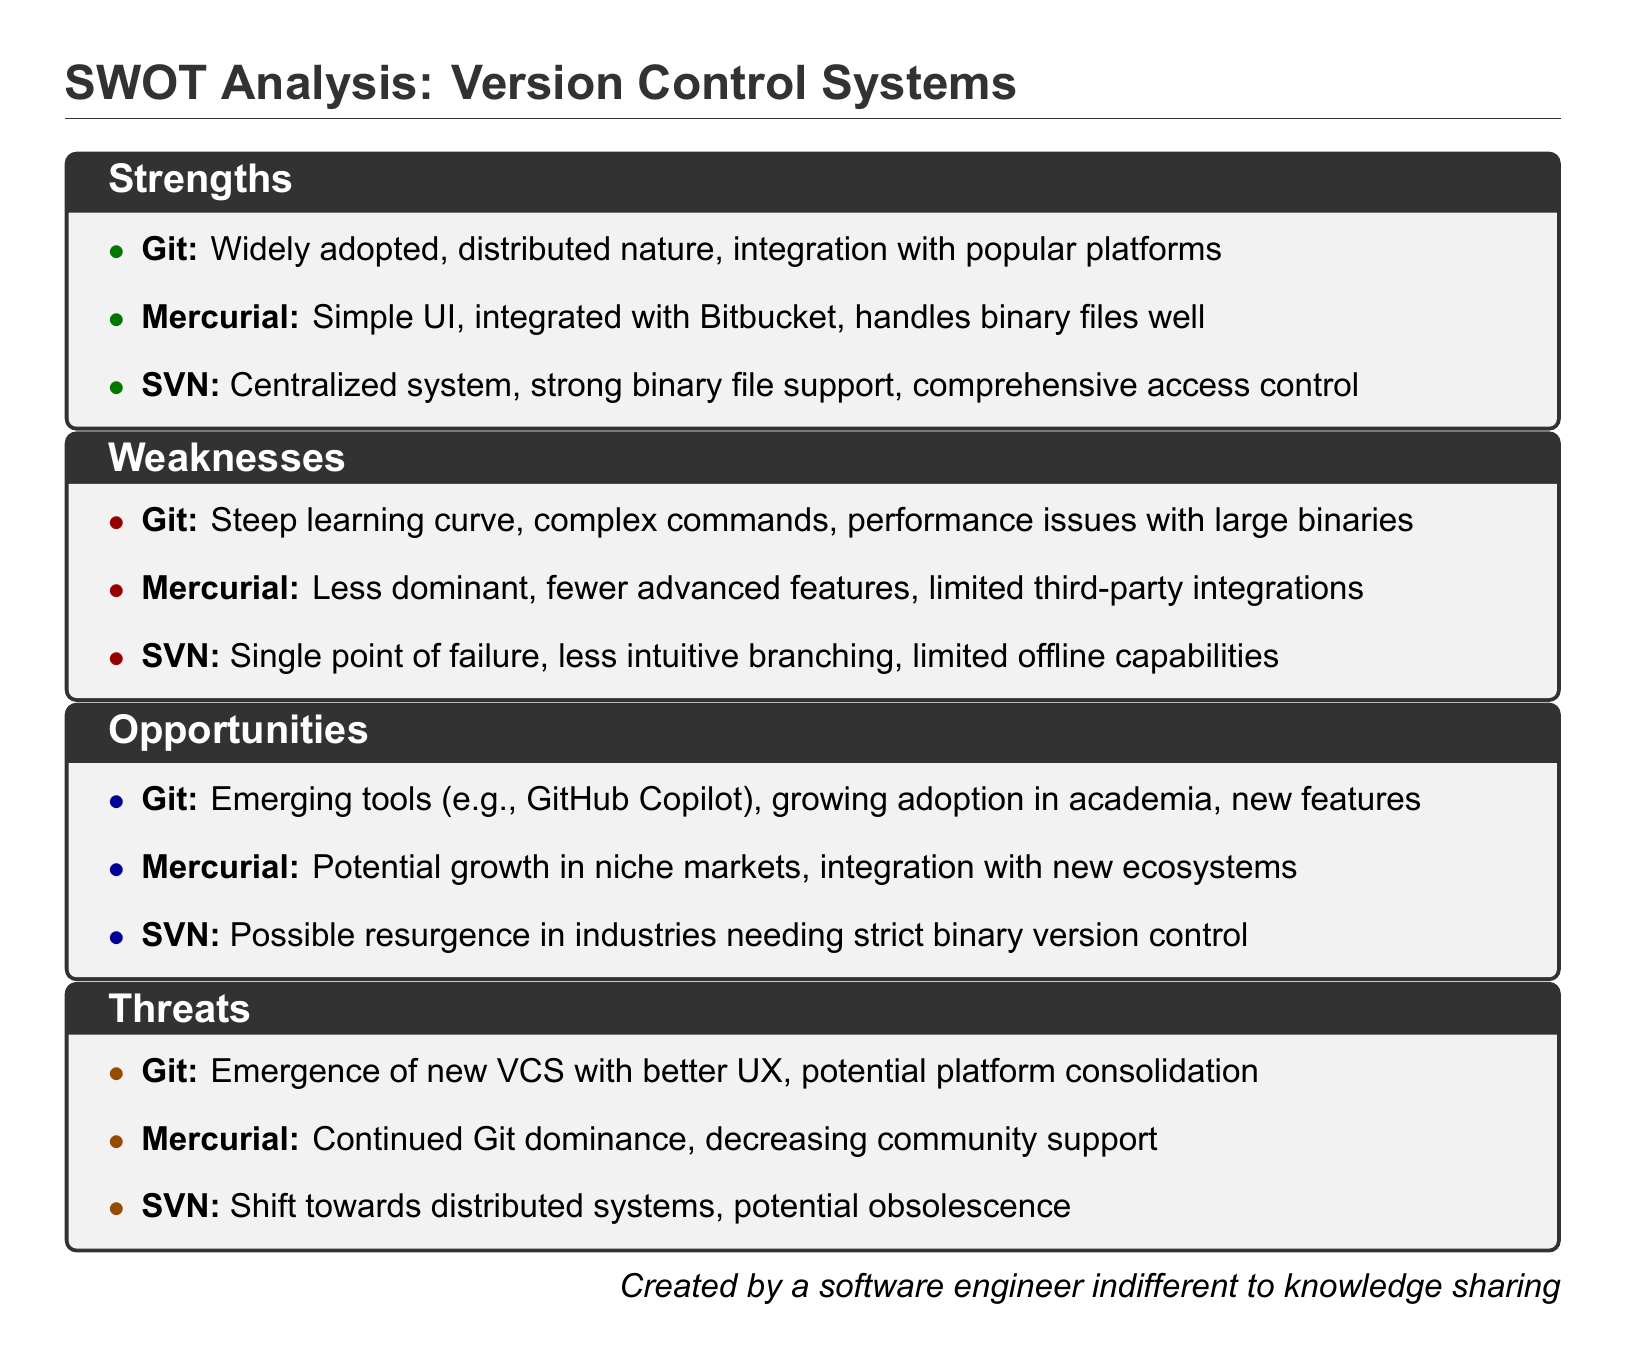What is the primary strength of Git? The primary strength of Git mentioned in the SWOT analysis is its widespread adoption and distributed nature.
Answer: Widely adopted, distributed nature What is a weakness of Mercurial? One of the weaknesses of Mercurial listed in the document is that it has fewer advanced features compared to others.
Answer: Fewer advanced features What opportunity exists for Git? An opportunity identified for Git is its potential for growth due to emerging tools like GitHub Copilot.
Answer: Emerging tools (e.g., GitHub Copilot) What threat does SVN face according to the document? According to the SWOT analysis, a threat to SVN is the shift towards distributed systems which may lead to its potential obsolescence.
Answer: Potential obsolescence Which version control system is centralized? The version control system described as centralized in the document is SVN.
Answer: SVN 